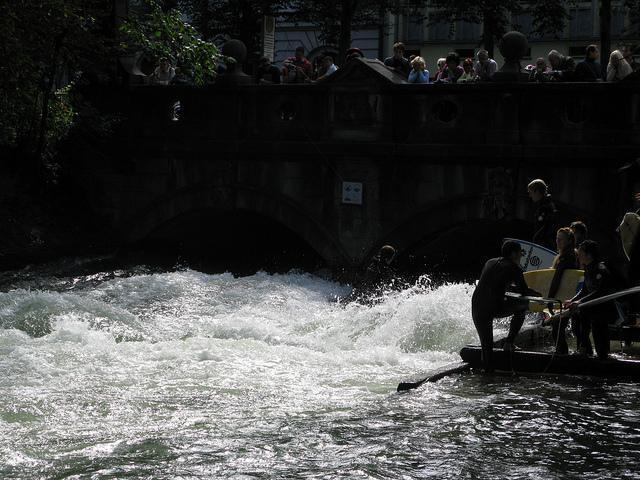How many people can be seen?
Give a very brief answer. 3. 